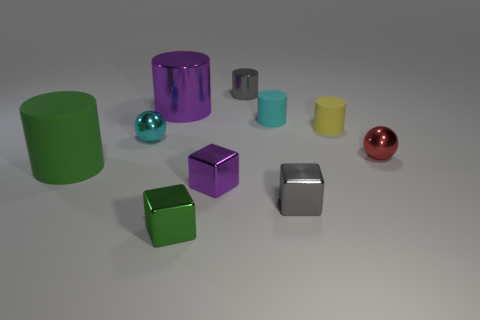Subtract all cyan cylinders. How many cylinders are left? 4 Subtract all big green matte cylinders. How many cylinders are left? 4 Subtract all red cylinders. Subtract all brown balls. How many cylinders are left? 5 Subtract all balls. How many objects are left? 8 Add 7 large metal objects. How many large metal objects are left? 8 Add 4 gray matte objects. How many gray matte objects exist? 4 Subtract 0 blue cubes. How many objects are left? 10 Subtract all big things. Subtract all cyan matte things. How many objects are left? 7 